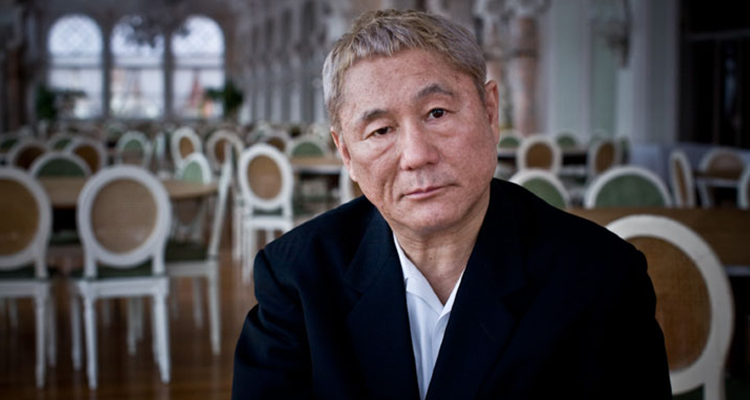What can you infer about the man's profession or personality based on his attire and demeanor in the image? The man's sharp black suit and the formal settings suggest a professional demeanor, potentially indicative of a business executive or a high-tier professional environment. His serious expression and contemplative pose could imply that he is a person who frequently engages in critical thinking or decision-making, perhaps in a leadership role. 